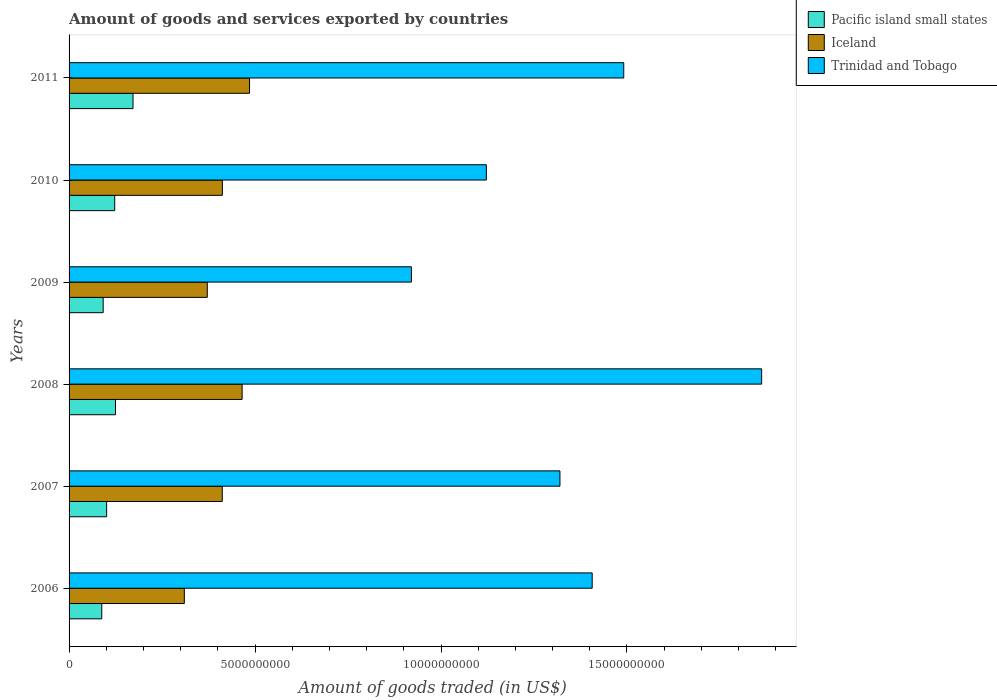How many different coloured bars are there?
Ensure brevity in your answer.  3. How many bars are there on the 6th tick from the top?
Your response must be concise. 3. What is the total amount of goods and services exported in Iceland in 2010?
Provide a short and direct response. 4.12e+09. Across all years, what is the maximum total amount of goods and services exported in Iceland?
Ensure brevity in your answer.  4.85e+09. Across all years, what is the minimum total amount of goods and services exported in Pacific island small states?
Offer a very short reply. 8.79e+08. In which year was the total amount of goods and services exported in Trinidad and Tobago maximum?
Provide a succinct answer. 2008. What is the total total amount of goods and services exported in Trinidad and Tobago in the graph?
Offer a very short reply. 8.12e+1. What is the difference between the total amount of goods and services exported in Trinidad and Tobago in 2007 and that in 2008?
Make the answer very short. -5.42e+09. What is the difference between the total amount of goods and services exported in Iceland in 2010 and the total amount of goods and services exported in Pacific island small states in 2008?
Offer a terse response. 2.87e+09. What is the average total amount of goods and services exported in Trinidad and Tobago per year?
Your answer should be very brief. 1.35e+1. In the year 2011, what is the difference between the total amount of goods and services exported in Pacific island small states and total amount of goods and services exported in Trinidad and Tobago?
Provide a succinct answer. -1.32e+1. In how many years, is the total amount of goods and services exported in Pacific island small states greater than 1000000000 US$?
Offer a very short reply. 4. What is the ratio of the total amount of goods and services exported in Iceland in 2007 to that in 2011?
Offer a terse response. 0.85. Is the difference between the total amount of goods and services exported in Pacific island small states in 2007 and 2008 greater than the difference between the total amount of goods and services exported in Trinidad and Tobago in 2007 and 2008?
Offer a terse response. Yes. What is the difference between the highest and the second highest total amount of goods and services exported in Trinidad and Tobago?
Your answer should be very brief. 3.71e+09. What is the difference between the highest and the lowest total amount of goods and services exported in Pacific island small states?
Your response must be concise. 8.40e+08. In how many years, is the total amount of goods and services exported in Iceland greater than the average total amount of goods and services exported in Iceland taken over all years?
Give a very brief answer. 4. Is the sum of the total amount of goods and services exported in Pacific island small states in 2007 and 2011 greater than the maximum total amount of goods and services exported in Trinidad and Tobago across all years?
Make the answer very short. No. Is it the case that in every year, the sum of the total amount of goods and services exported in Pacific island small states and total amount of goods and services exported in Iceland is greater than the total amount of goods and services exported in Trinidad and Tobago?
Your answer should be very brief. No. How many bars are there?
Offer a very short reply. 18. How many legend labels are there?
Offer a very short reply. 3. What is the title of the graph?
Make the answer very short. Amount of goods and services exported by countries. Does "Afghanistan" appear as one of the legend labels in the graph?
Offer a terse response. No. What is the label or title of the X-axis?
Your answer should be compact. Amount of goods traded (in US$). What is the label or title of the Y-axis?
Ensure brevity in your answer.  Years. What is the Amount of goods traded (in US$) in Pacific island small states in 2006?
Provide a succinct answer. 8.79e+08. What is the Amount of goods traded (in US$) in Iceland in 2006?
Offer a terse response. 3.10e+09. What is the Amount of goods traded (in US$) of Trinidad and Tobago in 2006?
Offer a very short reply. 1.41e+1. What is the Amount of goods traded (in US$) of Pacific island small states in 2007?
Your answer should be compact. 1.01e+09. What is the Amount of goods traded (in US$) in Iceland in 2007?
Provide a short and direct response. 4.12e+09. What is the Amount of goods traded (in US$) in Trinidad and Tobago in 2007?
Make the answer very short. 1.32e+1. What is the Amount of goods traded (in US$) of Pacific island small states in 2008?
Make the answer very short. 1.25e+09. What is the Amount of goods traded (in US$) of Iceland in 2008?
Your answer should be compact. 4.65e+09. What is the Amount of goods traded (in US$) of Trinidad and Tobago in 2008?
Your answer should be very brief. 1.86e+1. What is the Amount of goods traded (in US$) of Pacific island small states in 2009?
Your answer should be compact. 9.17e+08. What is the Amount of goods traded (in US$) in Iceland in 2009?
Your response must be concise. 3.72e+09. What is the Amount of goods traded (in US$) in Trinidad and Tobago in 2009?
Your answer should be compact. 9.20e+09. What is the Amount of goods traded (in US$) in Pacific island small states in 2010?
Provide a succinct answer. 1.23e+09. What is the Amount of goods traded (in US$) in Iceland in 2010?
Offer a terse response. 4.12e+09. What is the Amount of goods traded (in US$) in Trinidad and Tobago in 2010?
Keep it short and to the point. 1.12e+1. What is the Amount of goods traded (in US$) in Pacific island small states in 2011?
Your answer should be compact. 1.72e+09. What is the Amount of goods traded (in US$) of Iceland in 2011?
Give a very brief answer. 4.85e+09. What is the Amount of goods traded (in US$) in Trinidad and Tobago in 2011?
Make the answer very short. 1.49e+1. Across all years, what is the maximum Amount of goods traded (in US$) of Pacific island small states?
Offer a very short reply. 1.72e+09. Across all years, what is the maximum Amount of goods traded (in US$) of Iceland?
Keep it short and to the point. 4.85e+09. Across all years, what is the maximum Amount of goods traded (in US$) of Trinidad and Tobago?
Offer a terse response. 1.86e+1. Across all years, what is the minimum Amount of goods traded (in US$) in Pacific island small states?
Provide a short and direct response. 8.79e+08. Across all years, what is the minimum Amount of goods traded (in US$) in Iceland?
Give a very brief answer. 3.10e+09. Across all years, what is the minimum Amount of goods traded (in US$) of Trinidad and Tobago?
Provide a succinct answer. 9.20e+09. What is the total Amount of goods traded (in US$) in Pacific island small states in the graph?
Provide a succinct answer. 7.00e+09. What is the total Amount of goods traded (in US$) in Iceland in the graph?
Your answer should be compact. 2.46e+1. What is the total Amount of goods traded (in US$) of Trinidad and Tobago in the graph?
Your answer should be compact. 8.12e+1. What is the difference between the Amount of goods traded (in US$) of Pacific island small states in 2006 and that in 2007?
Make the answer very short. -1.31e+08. What is the difference between the Amount of goods traded (in US$) in Iceland in 2006 and that in 2007?
Ensure brevity in your answer.  -1.02e+09. What is the difference between the Amount of goods traded (in US$) of Trinidad and Tobago in 2006 and that in 2007?
Your answer should be very brief. 8.67e+08. What is the difference between the Amount of goods traded (in US$) in Pacific island small states in 2006 and that in 2008?
Make the answer very short. -3.69e+08. What is the difference between the Amount of goods traded (in US$) in Iceland in 2006 and that in 2008?
Offer a terse response. -1.55e+09. What is the difference between the Amount of goods traded (in US$) of Trinidad and Tobago in 2006 and that in 2008?
Give a very brief answer. -4.56e+09. What is the difference between the Amount of goods traded (in US$) in Pacific island small states in 2006 and that in 2009?
Ensure brevity in your answer.  -3.78e+07. What is the difference between the Amount of goods traded (in US$) of Iceland in 2006 and that in 2009?
Provide a short and direct response. -6.17e+08. What is the difference between the Amount of goods traded (in US$) in Trinidad and Tobago in 2006 and that in 2009?
Give a very brief answer. 4.86e+09. What is the difference between the Amount of goods traded (in US$) of Pacific island small states in 2006 and that in 2010?
Offer a very short reply. -3.48e+08. What is the difference between the Amount of goods traded (in US$) of Iceland in 2006 and that in 2010?
Your answer should be very brief. -1.02e+09. What is the difference between the Amount of goods traded (in US$) in Trinidad and Tobago in 2006 and that in 2010?
Your answer should be very brief. 2.85e+09. What is the difference between the Amount of goods traded (in US$) in Pacific island small states in 2006 and that in 2011?
Your answer should be compact. -8.40e+08. What is the difference between the Amount of goods traded (in US$) in Iceland in 2006 and that in 2011?
Provide a succinct answer. -1.75e+09. What is the difference between the Amount of goods traded (in US$) in Trinidad and Tobago in 2006 and that in 2011?
Make the answer very short. -8.49e+08. What is the difference between the Amount of goods traded (in US$) in Pacific island small states in 2007 and that in 2008?
Provide a short and direct response. -2.38e+08. What is the difference between the Amount of goods traded (in US$) of Iceland in 2007 and that in 2008?
Make the answer very short. -5.34e+08. What is the difference between the Amount of goods traded (in US$) of Trinidad and Tobago in 2007 and that in 2008?
Provide a short and direct response. -5.42e+09. What is the difference between the Amount of goods traded (in US$) of Pacific island small states in 2007 and that in 2009?
Keep it short and to the point. 9.31e+07. What is the difference between the Amount of goods traded (in US$) in Iceland in 2007 and that in 2009?
Give a very brief answer. 4.02e+08. What is the difference between the Amount of goods traded (in US$) in Trinidad and Tobago in 2007 and that in 2009?
Offer a terse response. 3.99e+09. What is the difference between the Amount of goods traded (in US$) of Pacific island small states in 2007 and that in 2010?
Ensure brevity in your answer.  -2.17e+08. What is the difference between the Amount of goods traded (in US$) of Iceland in 2007 and that in 2010?
Your response must be concise. -3.23e+06. What is the difference between the Amount of goods traded (in US$) of Trinidad and Tobago in 2007 and that in 2010?
Your answer should be compact. 1.98e+09. What is the difference between the Amount of goods traded (in US$) of Pacific island small states in 2007 and that in 2011?
Your response must be concise. -7.09e+08. What is the difference between the Amount of goods traded (in US$) in Iceland in 2007 and that in 2011?
Offer a terse response. -7.33e+08. What is the difference between the Amount of goods traded (in US$) of Trinidad and Tobago in 2007 and that in 2011?
Give a very brief answer. -1.72e+09. What is the difference between the Amount of goods traded (in US$) in Pacific island small states in 2008 and that in 2009?
Your answer should be compact. 3.31e+08. What is the difference between the Amount of goods traded (in US$) of Iceland in 2008 and that in 2009?
Offer a very short reply. 9.37e+08. What is the difference between the Amount of goods traded (in US$) in Trinidad and Tobago in 2008 and that in 2009?
Offer a terse response. 9.42e+09. What is the difference between the Amount of goods traded (in US$) in Pacific island small states in 2008 and that in 2010?
Keep it short and to the point. 2.08e+07. What is the difference between the Amount of goods traded (in US$) of Iceland in 2008 and that in 2010?
Give a very brief answer. 5.31e+08. What is the difference between the Amount of goods traded (in US$) of Trinidad and Tobago in 2008 and that in 2010?
Your answer should be very brief. 7.40e+09. What is the difference between the Amount of goods traded (in US$) in Pacific island small states in 2008 and that in 2011?
Make the answer very short. -4.71e+08. What is the difference between the Amount of goods traded (in US$) of Iceland in 2008 and that in 2011?
Your answer should be compact. -1.99e+08. What is the difference between the Amount of goods traded (in US$) in Trinidad and Tobago in 2008 and that in 2011?
Your response must be concise. 3.71e+09. What is the difference between the Amount of goods traded (in US$) in Pacific island small states in 2009 and that in 2010?
Your response must be concise. -3.11e+08. What is the difference between the Amount of goods traded (in US$) in Iceland in 2009 and that in 2010?
Keep it short and to the point. -4.06e+08. What is the difference between the Amount of goods traded (in US$) of Trinidad and Tobago in 2009 and that in 2010?
Offer a very short reply. -2.02e+09. What is the difference between the Amount of goods traded (in US$) of Pacific island small states in 2009 and that in 2011?
Offer a very short reply. -8.02e+08. What is the difference between the Amount of goods traded (in US$) of Iceland in 2009 and that in 2011?
Give a very brief answer. -1.14e+09. What is the difference between the Amount of goods traded (in US$) in Trinidad and Tobago in 2009 and that in 2011?
Your answer should be compact. -5.71e+09. What is the difference between the Amount of goods traded (in US$) of Pacific island small states in 2010 and that in 2011?
Your answer should be compact. -4.92e+08. What is the difference between the Amount of goods traded (in US$) of Iceland in 2010 and that in 2011?
Provide a succinct answer. -7.30e+08. What is the difference between the Amount of goods traded (in US$) in Trinidad and Tobago in 2010 and that in 2011?
Give a very brief answer. -3.69e+09. What is the difference between the Amount of goods traded (in US$) in Pacific island small states in 2006 and the Amount of goods traded (in US$) in Iceland in 2007?
Keep it short and to the point. -3.24e+09. What is the difference between the Amount of goods traded (in US$) of Pacific island small states in 2006 and the Amount of goods traded (in US$) of Trinidad and Tobago in 2007?
Make the answer very short. -1.23e+1. What is the difference between the Amount of goods traded (in US$) in Iceland in 2006 and the Amount of goods traded (in US$) in Trinidad and Tobago in 2007?
Keep it short and to the point. -1.01e+1. What is the difference between the Amount of goods traded (in US$) of Pacific island small states in 2006 and the Amount of goods traded (in US$) of Iceland in 2008?
Your response must be concise. -3.77e+09. What is the difference between the Amount of goods traded (in US$) in Pacific island small states in 2006 and the Amount of goods traded (in US$) in Trinidad and Tobago in 2008?
Your answer should be compact. -1.77e+1. What is the difference between the Amount of goods traded (in US$) of Iceland in 2006 and the Amount of goods traded (in US$) of Trinidad and Tobago in 2008?
Provide a short and direct response. -1.55e+1. What is the difference between the Amount of goods traded (in US$) in Pacific island small states in 2006 and the Amount of goods traded (in US$) in Iceland in 2009?
Make the answer very short. -2.84e+09. What is the difference between the Amount of goods traded (in US$) of Pacific island small states in 2006 and the Amount of goods traded (in US$) of Trinidad and Tobago in 2009?
Give a very brief answer. -8.32e+09. What is the difference between the Amount of goods traded (in US$) in Iceland in 2006 and the Amount of goods traded (in US$) in Trinidad and Tobago in 2009?
Offer a terse response. -6.11e+09. What is the difference between the Amount of goods traded (in US$) of Pacific island small states in 2006 and the Amount of goods traded (in US$) of Iceland in 2010?
Keep it short and to the point. -3.24e+09. What is the difference between the Amount of goods traded (in US$) in Pacific island small states in 2006 and the Amount of goods traded (in US$) in Trinidad and Tobago in 2010?
Provide a succinct answer. -1.03e+1. What is the difference between the Amount of goods traded (in US$) of Iceland in 2006 and the Amount of goods traded (in US$) of Trinidad and Tobago in 2010?
Ensure brevity in your answer.  -8.12e+09. What is the difference between the Amount of goods traded (in US$) in Pacific island small states in 2006 and the Amount of goods traded (in US$) in Iceland in 2011?
Your answer should be compact. -3.97e+09. What is the difference between the Amount of goods traded (in US$) in Pacific island small states in 2006 and the Amount of goods traded (in US$) in Trinidad and Tobago in 2011?
Make the answer very short. -1.40e+1. What is the difference between the Amount of goods traded (in US$) of Iceland in 2006 and the Amount of goods traded (in US$) of Trinidad and Tobago in 2011?
Your response must be concise. -1.18e+1. What is the difference between the Amount of goods traded (in US$) of Pacific island small states in 2007 and the Amount of goods traded (in US$) of Iceland in 2008?
Give a very brief answer. -3.64e+09. What is the difference between the Amount of goods traded (in US$) in Pacific island small states in 2007 and the Amount of goods traded (in US$) in Trinidad and Tobago in 2008?
Give a very brief answer. -1.76e+1. What is the difference between the Amount of goods traded (in US$) in Iceland in 2007 and the Amount of goods traded (in US$) in Trinidad and Tobago in 2008?
Offer a terse response. -1.45e+1. What is the difference between the Amount of goods traded (in US$) of Pacific island small states in 2007 and the Amount of goods traded (in US$) of Iceland in 2009?
Your answer should be compact. -2.71e+09. What is the difference between the Amount of goods traded (in US$) in Pacific island small states in 2007 and the Amount of goods traded (in US$) in Trinidad and Tobago in 2009?
Your response must be concise. -8.19e+09. What is the difference between the Amount of goods traded (in US$) of Iceland in 2007 and the Amount of goods traded (in US$) of Trinidad and Tobago in 2009?
Make the answer very short. -5.09e+09. What is the difference between the Amount of goods traded (in US$) in Pacific island small states in 2007 and the Amount of goods traded (in US$) in Iceland in 2010?
Make the answer very short. -3.11e+09. What is the difference between the Amount of goods traded (in US$) in Pacific island small states in 2007 and the Amount of goods traded (in US$) in Trinidad and Tobago in 2010?
Offer a very short reply. -1.02e+1. What is the difference between the Amount of goods traded (in US$) in Iceland in 2007 and the Amount of goods traded (in US$) in Trinidad and Tobago in 2010?
Your answer should be compact. -7.10e+09. What is the difference between the Amount of goods traded (in US$) of Pacific island small states in 2007 and the Amount of goods traded (in US$) of Iceland in 2011?
Your answer should be very brief. -3.84e+09. What is the difference between the Amount of goods traded (in US$) of Pacific island small states in 2007 and the Amount of goods traded (in US$) of Trinidad and Tobago in 2011?
Your response must be concise. -1.39e+1. What is the difference between the Amount of goods traded (in US$) in Iceland in 2007 and the Amount of goods traded (in US$) in Trinidad and Tobago in 2011?
Offer a very short reply. -1.08e+1. What is the difference between the Amount of goods traded (in US$) of Pacific island small states in 2008 and the Amount of goods traded (in US$) of Iceland in 2009?
Your answer should be very brief. -2.47e+09. What is the difference between the Amount of goods traded (in US$) of Pacific island small states in 2008 and the Amount of goods traded (in US$) of Trinidad and Tobago in 2009?
Your answer should be compact. -7.96e+09. What is the difference between the Amount of goods traded (in US$) in Iceland in 2008 and the Amount of goods traded (in US$) in Trinidad and Tobago in 2009?
Make the answer very short. -4.55e+09. What is the difference between the Amount of goods traded (in US$) in Pacific island small states in 2008 and the Amount of goods traded (in US$) in Iceland in 2010?
Make the answer very short. -2.87e+09. What is the difference between the Amount of goods traded (in US$) in Pacific island small states in 2008 and the Amount of goods traded (in US$) in Trinidad and Tobago in 2010?
Your answer should be compact. -9.97e+09. What is the difference between the Amount of goods traded (in US$) in Iceland in 2008 and the Amount of goods traded (in US$) in Trinidad and Tobago in 2010?
Offer a very short reply. -6.57e+09. What is the difference between the Amount of goods traded (in US$) in Pacific island small states in 2008 and the Amount of goods traded (in US$) in Iceland in 2011?
Give a very brief answer. -3.60e+09. What is the difference between the Amount of goods traded (in US$) in Pacific island small states in 2008 and the Amount of goods traded (in US$) in Trinidad and Tobago in 2011?
Your answer should be compact. -1.37e+1. What is the difference between the Amount of goods traded (in US$) in Iceland in 2008 and the Amount of goods traded (in US$) in Trinidad and Tobago in 2011?
Offer a terse response. -1.03e+1. What is the difference between the Amount of goods traded (in US$) of Pacific island small states in 2009 and the Amount of goods traded (in US$) of Iceland in 2010?
Your answer should be compact. -3.20e+09. What is the difference between the Amount of goods traded (in US$) of Pacific island small states in 2009 and the Amount of goods traded (in US$) of Trinidad and Tobago in 2010?
Keep it short and to the point. -1.03e+1. What is the difference between the Amount of goods traded (in US$) in Iceland in 2009 and the Amount of goods traded (in US$) in Trinidad and Tobago in 2010?
Provide a short and direct response. -7.50e+09. What is the difference between the Amount of goods traded (in US$) of Pacific island small states in 2009 and the Amount of goods traded (in US$) of Iceland in 2011?
Make the answer very short. -3.94e+09. What is the difference between the Amount of goods traded (in US$) in Pacific island small states in 2009 and the Amount of goods traded (in US$) in Trinidad and Tobago in 2011?
Offer a very short reply. -1.40e+1. What is the difference between the Amount of goods traded (in US$) of Iceland in 2009 and the Amount of goods traded (in US$) of Trinidad and Tobago in 2011?
Ensure brevity in your answer.  -1.12e+1. What is the difference between the Amount of goods traded (in US$) of Pacific island small states in 2010 and the Amount of goods traded (in US$) of Iceland in 2011?
Keep it short and to the point. -3.62e+09. What is the difference between the Amount of goods traded (in US$) of Pacific island small states in 2010 and the Amount of goods traded (in US$) of Trinidad and Tobago in 2011?
Provide a short and direct response. -1.37e+1. What is the difference between the Amount of goods traded (in US$) in Iceland in 2010 and the Amount of goods traded (in US$) in Trinidad and Tobago in 2011?
Your answer should be compact. -1.08e+1. What is the average Amount of goods traded (in US$) of Pacific island small states per year?
Provide a short and direct response. 1.17e+09. What is the average Amount of goods traded (in US$) in Iceland per year?
Provide a succinct answer. 4.09e+09. What is the average Amount of goods traded (in US$) of Trinidad and Tobago per year?
Provide a short and direct response. 1.35e+1. In the year 2006, what is the difference between the Amount of goods traded (in US$) in Pacific island small states and Amount of goods traded (in US$) in Iceland?
Provide a succinct answer. -2.22e+09. In the year 2006, what is the difference between the Amount of goods traded (in US$) of Pacific island small states and Amount of goods traded (in US$) of Trinidad and Tobago?
Keep it short and to the point. -1.32e+1. In the year 2006, what is the difference between the Amount of goods traded (in US$) in Iceland and Amount of goods traded (in US$) in Trinidad and Tobago?
Provide a short and direct response. -1.10e+1. In the year 2007, what is the difference between the Amount of goods traded (in US$) of Pacific island small states and Amount of goods traded (in US$) of Iceland?
Your answer should be very brief. -3.11e+09. In the year 2007, what is the difference between the Amount of goods traded (in US$) of Pacific island small states and Amount of goods traded (in US$) of Trinidad and Tobago?
Offer a very short reply. -1.22e+1. In the year 2007, what is the difference between the Amount of goods traded (in US$) of Iceland and Amount of goods traded (in US$) of Trinidad and Tobago?
Your response must be concise. -9.08e+09. In the year 2008, what is the difference between the Amount of goods traded (in US$) of Pacific island small states and Amount of goods traded (in US$) of Iceland?
Offer a very short reply. -3.40e+09. In the year 2008, what is the difference between the Amount of goods traded (in US$) of Pacific island small states and Amount of goods traded (in US$) of Trinidad and Tobago?
Provide a succinct answer. -1.74e+1. In the year 2008, what is the difference between the Amount of goods traded (in US$) in Iceland and Amount of goods traded (in US$) in Trinidad and Tobago?
Provide a short and direct response. -1.40e+1. In the year 2009, what is the difference between the Amount of goods traded (in US$) in Pacific island small states and Amount of goods traded (in US$) in Iceland?
Offer a very short reply. -2.80e+09. In the year 2009, what is the difference between the Amount of goods traded (in US$) of Pacific island small states and Amount of goods traded (in US$) of Trinidad and Tobago?
Make the answer very short. -8.29e+09. In the year 2009, what is the difference between the Amount of goods traded (in US$) of Iceland and Amount of goods traded (in US$) of Trinidad and Tobago?
Offer a very short reply. -5.49e+09. In the year 2010, what is the difference between the Amount of goods traded (in US$) in Pacific island small states and Amount of goods traded (in US$) in Iceland?
Provide a short and direct response. -2.89e+09. In the year 2010, what is the difference between the Amount of goods traded (in US$) of Pacific island small states and Amount of goods traded (in US$) of Trinidad and Tobago?
Ensure brevity in your answer.  -9.99e+09. In the year 2010, what is the difference between the Amount of goods traded (in US$) of Iceland and Amount of goods traded (in US$) of Trinidad and Tobago?
Offer a very short reply. -7.10e+09. In the year 2011, what is the difference between the Amount of goods traded (in US$) in Pacific island small states and Amount of goods traded (in US$) in Iceland?
Offer a very short reply. -3.13e+09. In the year 2011, what is the difference between the Amount of goods traded (in US$) in Pacific island small states and Amount of goods traded (in US$) in Trinidad and Tobago?
Ensure brevity in your answer.  -1.32e+1. In the year 2011, what is the difference between the Amount of goods traded (in US$) of Iceland and Amount of goods traded (in US$) of Trinidad and Tobago?
Make the answer very short. -1.01e+1. What is the ratio of the Amount of goods traded (in US$) in Pacific island small states in 2006 to that in 2007?
Provide a short and direct response. 0.87. What is the ratio of the Amount of goods traded (in US$) in Iceland in 2006 to that in 2007?
Keep it short and to the point. 0.75. What is the ratio of the Amount of goods traded (in US$) of Trinidad and Tobago in 2006 to that in 2007?
Your answer should be very brief. 1.07. What is the ratio of the Amount of goods traded (in US$) in Pacific island small states in 2006 to that in 2008?
Your answer should be compact. 0.7. What is the ratio of the Amount of goods traded (in US$) in Iceland in 2006 to that in 2008?
Provide a succinct answer. 0.67. What is the ratio of the Amount of goods traded (in US$) in Trinidad and Tobago in 2006 to that in 2008?
Make the answer very short. 0.76. What is the ratio of the Amount of goods traded (in US$) in Pacific island small states in 2006 to that in 2009?
Provide a succinct answer. 0.96. What is the ratio of the Amount of goods traded (in US$) in Iceland in 2006 to that in 2009?
Keep it short and to the point. 0.83. What is the ratio of the Amount of goods traded (in US$) in Trinidad and Tobago in 2006 to that in 2009?
Give a very brief answer. 1.53. What is the ratio of the Amount of goods traded (in US$) in Pacific island small states in 2006 to that in 2010?
Your answer should be compact. 0.72. What is the ratio of the Amount of goods traded (in US$) in Iceland in 2006 to that in 2010?
Offer a terse response. 0.75. What is the ratio of the Amount of goods traded (in US$) in Trinidad and Tobago in 2006 to that in 2010?
Your response must be concise. 1.25. What is the ratio of the Amount of goods traded (in US$) of Pacific island small states in 2006 to that in 2011?
Make the answer very short. 0.51. What is the ratio of the Amount of goods traded (in US$) in Iceland in 2006 to that in 2011?
Offer a very short reply. 0.64. What is the ratio of the Amount of goods traded (in US$) in Trinidad and Tobago in 2006 to that in 2011?
Make the answer very short. 0.94. What is the ratio of the Amount of goods traded (in US$) in Pacific island small states in 2007 to that in 2008?
Your answer should be compact. 0.81. What is the ratio of the Amount of goods traded (in US$) in Iceland in 2007 to that in 2008?
Your answer should be very brief. 0.89. What is the ratio of the Amount of goods traded (in US$) in Trinidad and Tobago in 2007 to that in 2008?
Your response must be concise. 0.71. What is the ratio of the Amount of goods traded (in US$) of Pacific island small states in 2007 to that in 2009?
Provide a short and direct response. 1.1. What is the ratio of the Amount of goods traded (in US$) in Iceland in 2007 to that in 2009?
Keep it short and to the point. 1.11. What is the ratio of the Amount of goods traded (in US$) in Trinidad and Tobago in 2007 to that in 2009?
Offer a terse response. 1.43. What is the ratio of the Amount of goods traded (in US$) in Pacific island small states in 2007 to that in 2010?
Your response must be concise. 0.82. What is the ratio of the Amount of goods traded (in US$) in Iceland in 2007 to that in 2010?
Your response must be concise. 1. What is the ratio of the Amount of goods traded (in US$) of Trinidad and Tobago in 2007 to that in 2010?
Your answer should be compact. 1.18. What is the ratio of the Amount of goods traded (in US$) of Pacific island small states in 2007 to that in 2011?
Your response must be concise. 0.59. What is the ratio of the Amount of goods traded (in US$) in Iceland in 2007 to that in 2011?
Make the answer very short. 0.85. What is the ratio of the Amount of goods traded (in US$) in Trinidad and Tobago in 2007 to that in 2011?
Offer a terse response. 0.89. What is the ratio of the Amount of goods traded (in US$) in Pacific island small states in 2008 to that in 2009?
Offer a terse response. 1.36. What is the ratio of the Amount of goods traded (in US$) of Iceland in 2008 to that in 2009?
Your response must be concise. 1.25. What is the ratio of the Amount of goods traded (in US$) in Trinidad and Tobago in 2008 to that in 2009?
Your response must be concise. 2.02. What is the ratio of the Amount of goods traded (in US$) in Pacific island small states in 2008 to that in 2010?
Give a very brief answer. 1.02. What is the ratio of the Amount of goods traded (in US$) of Iceland in 2008 to that in 2010?
Give a very brief answer. 1.13. What is the ratio of the Amount of goods traded (in US$) in Trinidad and Tobago in 2008 to that in 2010?
Your answer should be very brief. 1.66. What is the ratio of the Amount of goods traded (in US$) of Pacific island small states in 2008 to that in 2011?
Keep it short and to the point. 0.73. What is the ratio of the Amount of goods traded (in US$) of Trinidad and Tobago in 2008 to that in 2011?
Your answer should be very brief. 1.25. What is the ratio of the Amount of goods traded (in US$) in Pacific island small states in 2009 to that in 2010?
Offer a very short reply. 0.75. What is the ratio of the Amount of goods traded (in US$) in Iceland in 2009 to that in 2010?
Your response must be concise. 0.9. What is the ratio of the Amount of goods traded (in US$) of Trinidad and Tobago in 2009 to that in 2010?
Provide a short and direct response. 0.82. What is the ratio of the Amount of goods traded (in US$) of Pacific island small states in 2009 to that in 2011?
Make the answer very short. 0.53. What is the ratio of the Amount of goods traded (in US$) of Iceland in 2009 to that in 2011?
Make the answer very short. 0.77. What is the ratio of the Amount of goods traded (in US$) in Trinidad and Tobago in 2009 to that in 2011?
Give a very brief answer. 0.62. What is the ratio of the Amount of goods traded (in US$) of Pacific island small states in 2010 to that in 2011?
Provide a short and direct response. 0.71. What is the ratio of the Amount of goods traded (in US$) of Iceland in 2010 to that in 2011?
Offer a terse response. 0.85. What is the ratio of the Amount of goods traded (in US$) in Trinidad and Tobago in 2010 to that in 2011?
Keep it short and to the point. 0.75. What is the difference between the highest and the second highest Amount of goods traded (in US$) in Pacific island small states?
Provide a short and direct response. 4.71e+08. What is the difference between the highest and the second highest Amount of goods traded (in US$) of Iceland?
Give a very brief answer. 1.99e+08. What is the difference between the highest and the second highest Amount of goods traded (in US$) in Trinidad and Tobago?
Give a very brief answer. 3.71e+09. What is the difference between the highest and the lowest Amount of goods traded (in US$) of Pacific island small states?
Your response must be concise. 8.40e+08. What is the difference between the highest and the lowest Amount of goods traded (in US$) of Iceland?
Your answer should be compact. 1.75e+09. What is the difference between the highest and the lowest Amount of goods traded (in US$) in Trinidad and Tobago?
Offer a terse response. 9.42e+09. 